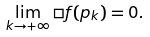<formula> <loc_0><loc_0><loc_500><loc_500>\lim _ { k \rightarrow + \infty } \square f ( p _ { k } ) = 0 .</formula> 